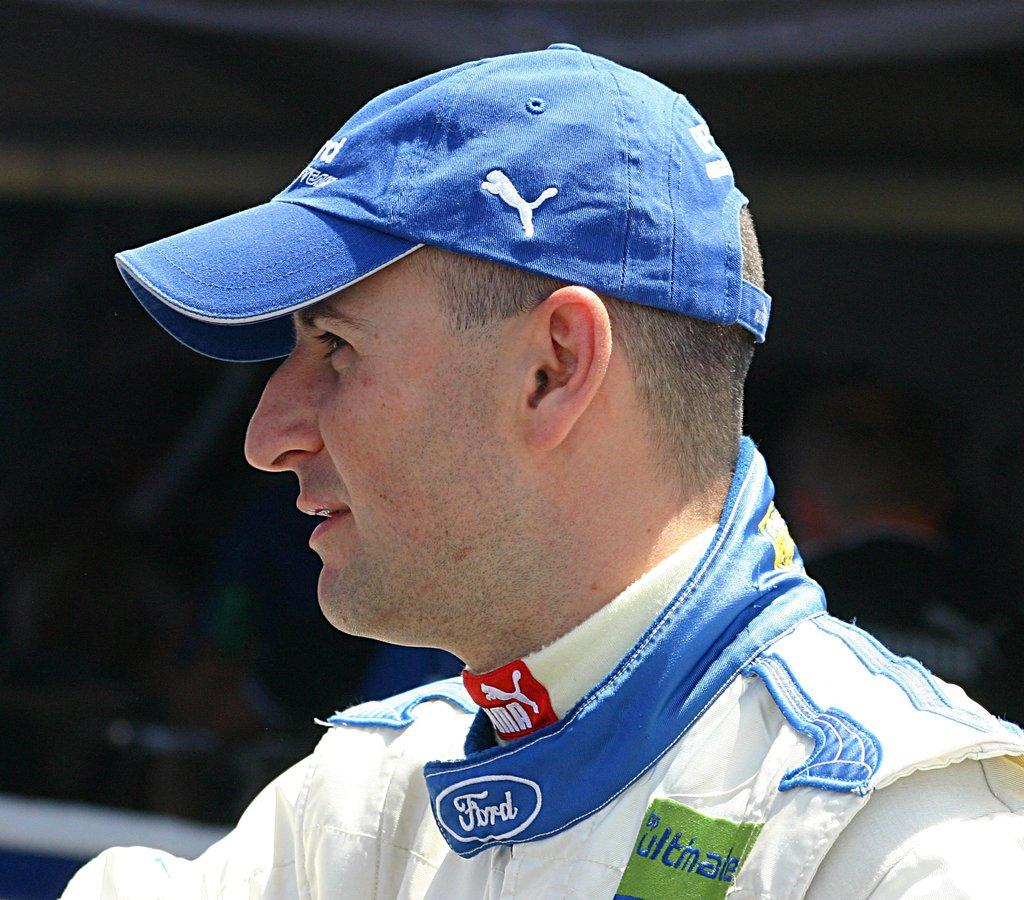<image>
Render a clear and concise summary of the photo. The car being advertised on the jacked is Ford. 